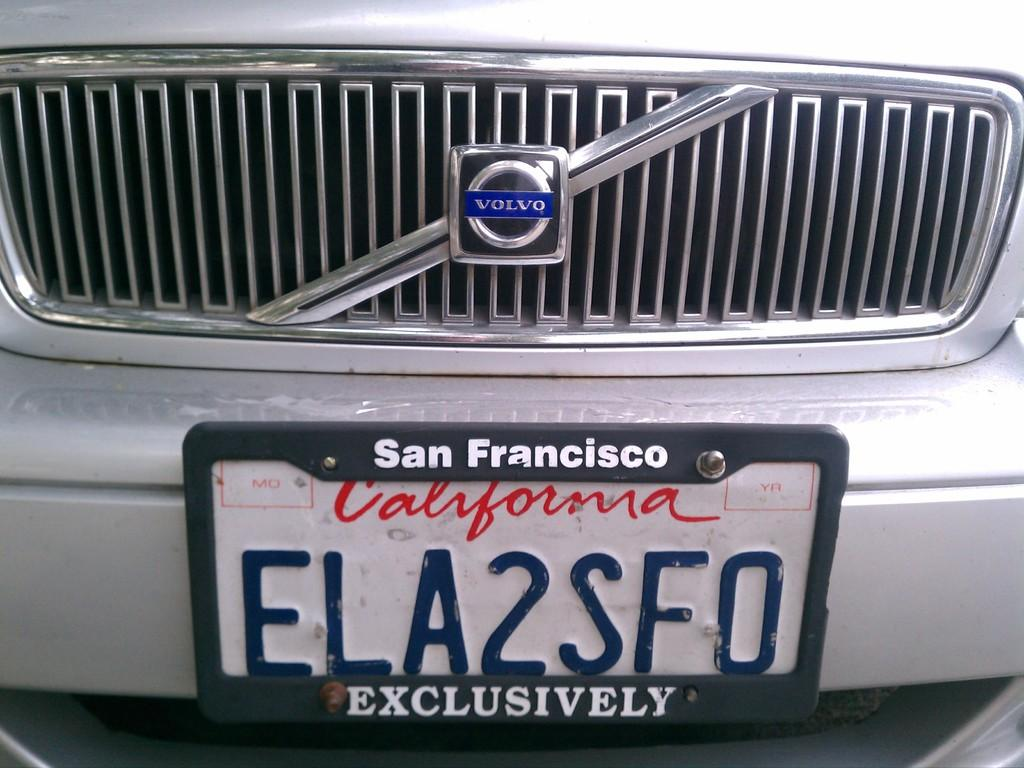<image>
Describe the image concisely. The license plate and grill of a Volvo from California is shown. 